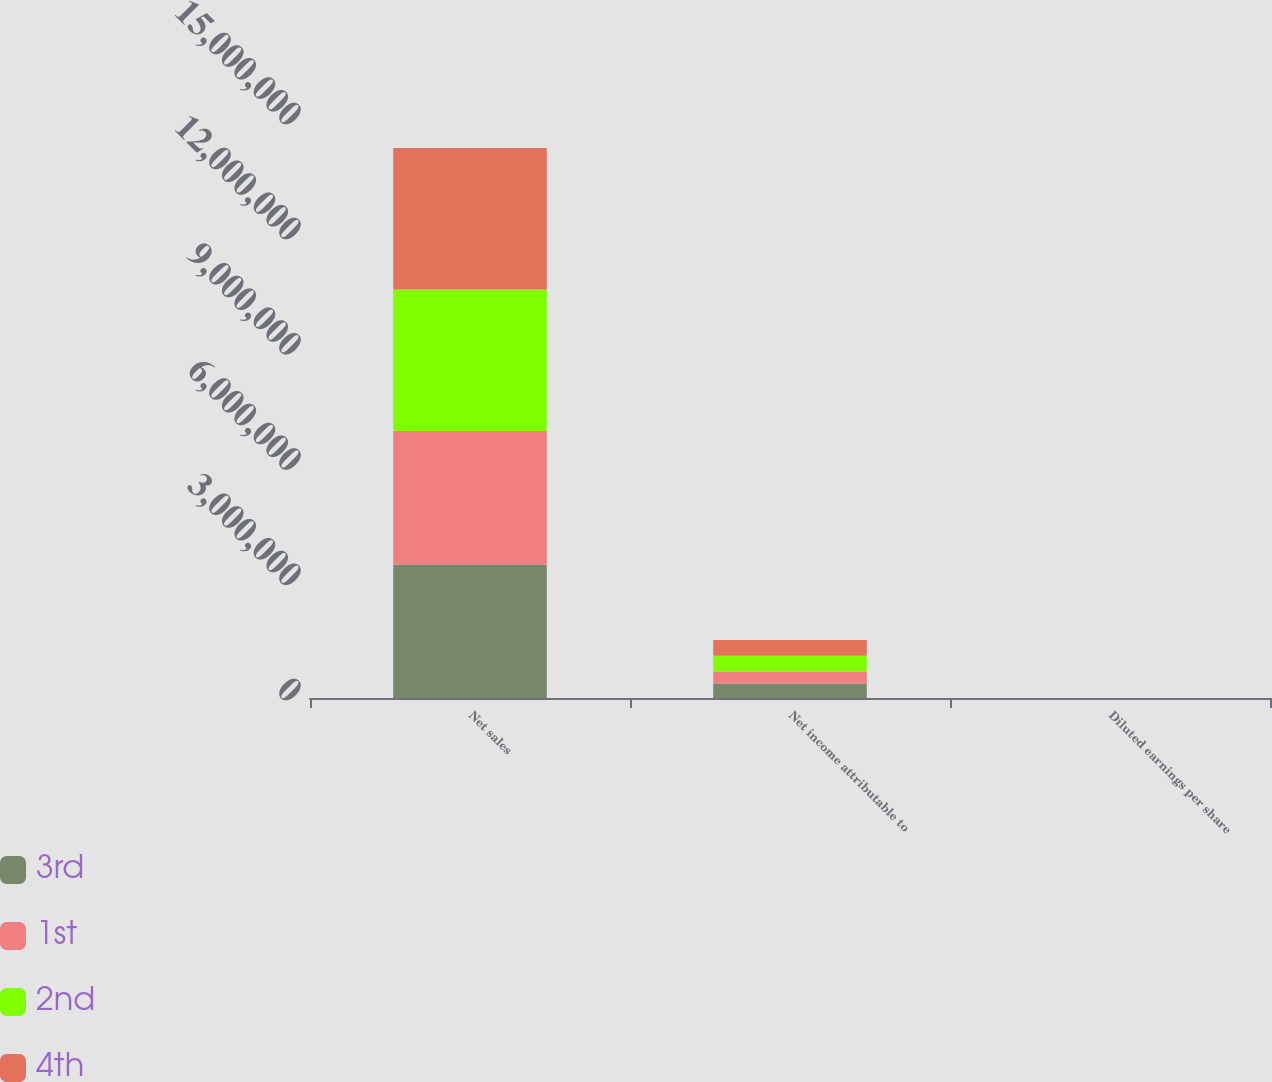Convert chart. <chart><loc_0><loc_0><loc_500><loc_500><stacked_bar_chart><ecel><fcel>Net sales<fcel>Net income attributable to<fcel>Diluted earnings per share<nl><fcel>3rd<fcel>3.47929e+06<fcel>375711<fcel>2.79<nl><fcel>1st<fcel>3.47204e+06<fcel>311737<fcel>2.36<nl><fcel>2nd<fcel>3.68752e+06<fcel>411248<fcel>3.14<nl><fcel>4th<fcel>3.68147e+06<fcel>413668<fcel>3.17<nl></chart> 